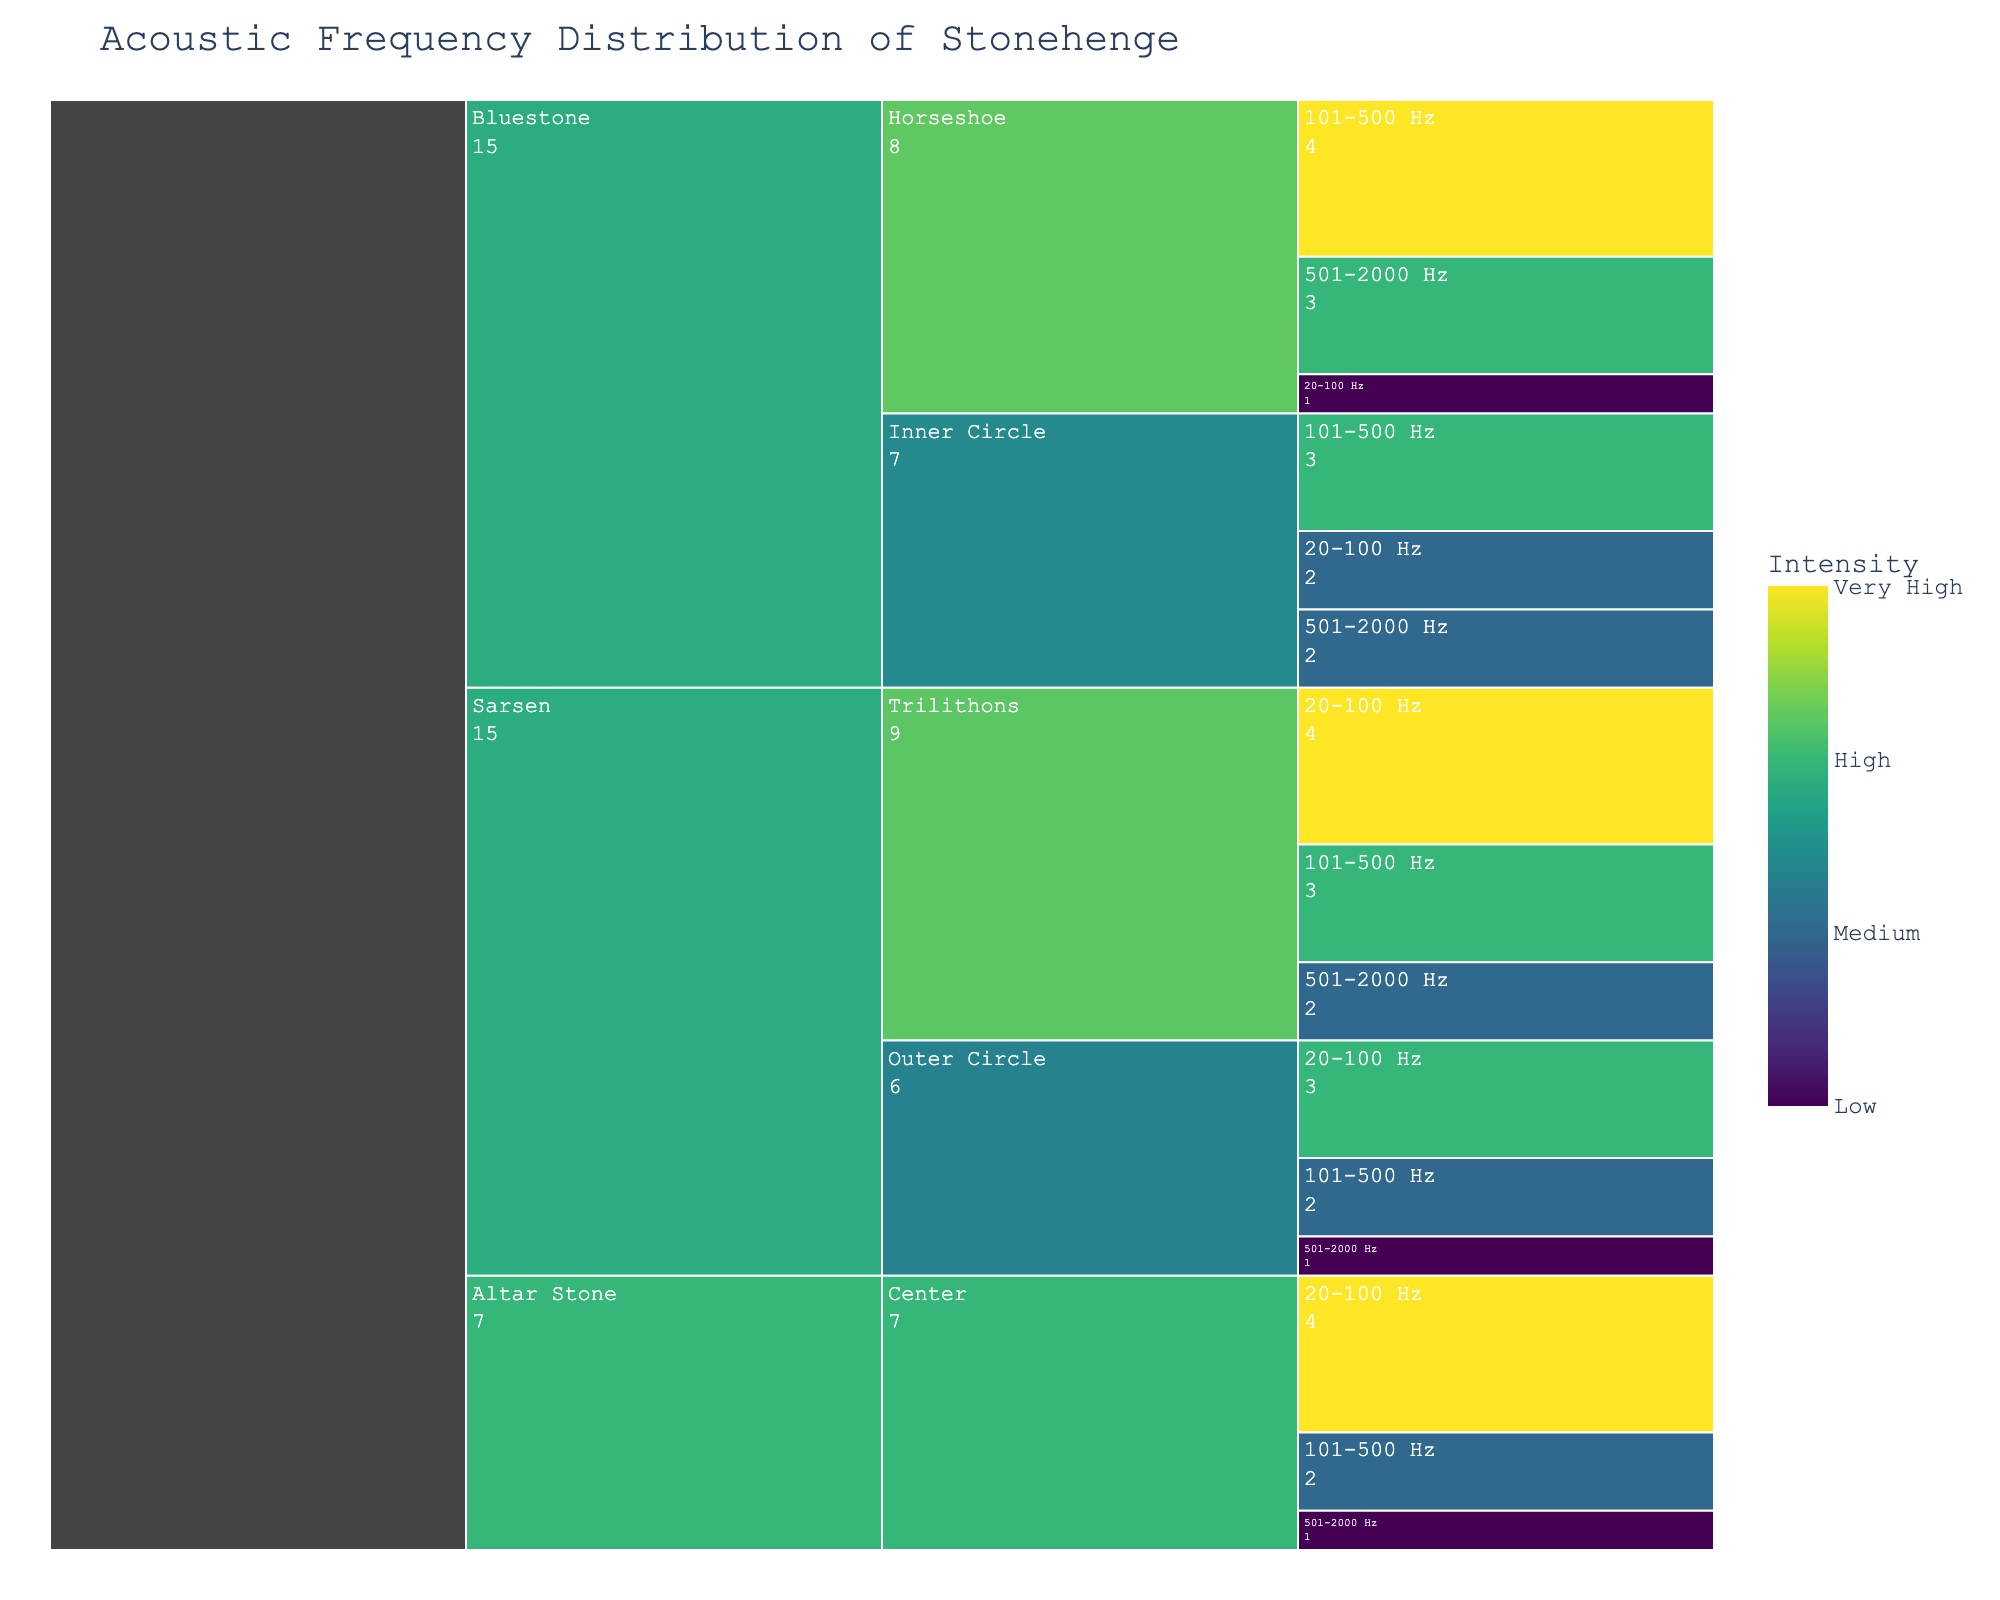What's the title of the chart? The title of the chart is displayed at the top of the figure in larger, bold font.
Answer: Acoustic Frequency Distribution of Stonehenge How many stone types are represented in the chart? The chart uses the Icicle format where each major branch represents a unique stone type. By counting these major branches, you can identify the number of stone types.
Answer: 3 Which location has the highest intensity for the Sarsen stone type in the 20-100 Hz frequency range? Look at the branch for Sarsen stone type, navigate to its sub-branch for each location, and find the 20-100 Hz frequency sub-branch. Check the color intensity or value for each.
Answer: Trilithons What is the intensity for Bluestone at Horseshoe in the 101-500 Hz frequency range? Navigate to the Bluestone stone type branch, then to the Horseshoe location sub-branch, and find the sub-branch for 101-500 Hz frequency. Look at the color or value indicated.
Answer: Very High Compare the intensity levels of 501-2000 Hz frequency for Bluestone in the Inner Circle and Horseshoe locations. Which one is higher? Find the Bluestone branch and navigate to both Inner Circle and Horseshoe locations. For each, find the 501-2000 Hz frequency sub-branch and compare the intensities.
Answer: Horseshoe Which stone type and location combination has the lowest intensity in the 20-100 Hz frequency range? Navigate through the branches for each stone type and their respective locations, and find the 20-100 Hz frequency sub-branches. Look for the one with the lowest intensity value indicated.
Answer: Bluestone, Horseshoe What's the cumulative intensity value for Sarsen stones in Outer Circle across all frequency ranges? For the Outer Circle under Sarsen, sum the intensity values across all frequency ranges: (High=3) + (Medium=2) + (Low=1).
Answer: 6 Which frequency range has the highest intensity for Altar Stone in the Center location? Navigate to the Altar Stone branch, find the Center location sub-branch, and compare intensity values across the frequency ranges.
Answer: 20-100 Hz How do the intensity levels compare between Sarsen (Trilithons) and Bluestone (Inner Circle) in the 101-500 Hz range? Look for the respective branches for Sarsen in Trilithons and Bluestone in Inner Circle, then compare their intensity values for the 101-500 Hz frequency range.
Answer: Sarsen (High) is less intense than Bluestone (High) What is the most common intensity level in the chart across all stone types and locations? By observing the color intensity or values across all branches and sub-branches, identify the intensity level that appears most frequently.
Answer: High 